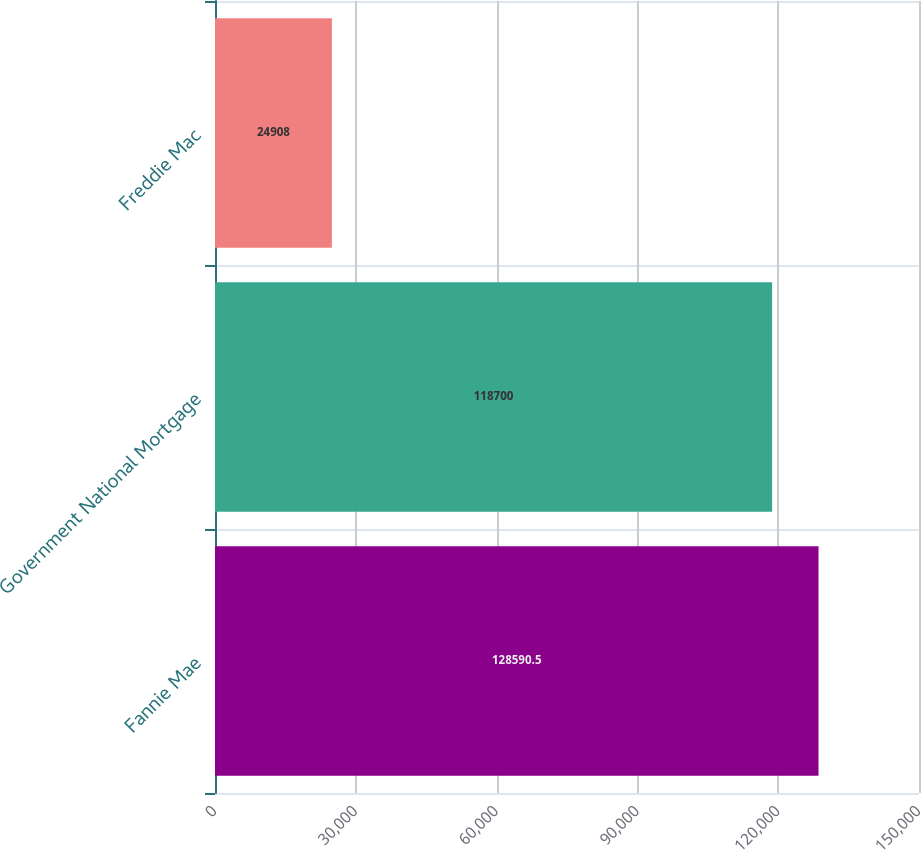Convert chart to OTSL. <chart><loc_0><loc_0><loc_500><loc_500><bar_chart><fcel>Fannie Mae<fcel>Government National Mortgage<fcel>Freddie Mac<nl><fcel>128590<fcel>118700<fcel>24908<nl></chart> 